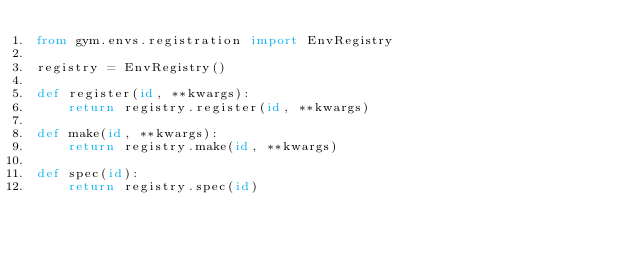Convert code to text. <code><loc_0><loc_0><loc_500><loc_500><_Python_>from gym.envs.registration import EnvRegistry

registry = EnvRegistry()

def register(id, **kwargs):
    return registry.register(id, **kwargs)

def make(id, **kwargs):
    return registry.make(id, **kwargs)

def spec(id):
    return registry.spec(id)</code> 